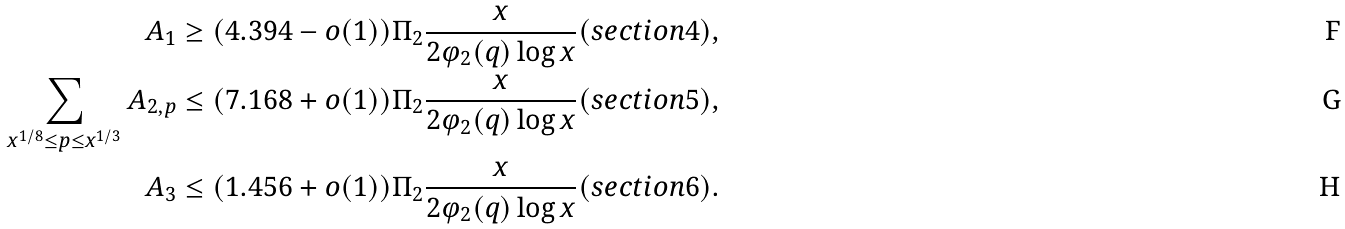Convert formula to latex. <formula><loc_0><loc_0><loc_500><loc_500>A _ { 1 } & \geq ( 4 . 3 9 4 - o ( 1 ) ) \Pi _ { 2 } \frac { x } { 2 \varphi _ { 2 } ( q ) \log x } ( s e c t i o n 4 ) , \\ \sum _ { x ^ { 1 / 8 } \leq p \leq x ^ { 1 / 3 } } A _ { 2 , p } & \leq ( 7 . 1 6 8 + o ( 1 ) ) \Pi _ { 2 } \frac { x } { 2 \varphi _ { 2 } ( q ) \log x } ( s e c t i o n 5 ) , \\ A _ { 3 } & \leq ( 1 . 4 5 6 + o ( 1 ) ) \Pi _ { 2 } \frac { x } { 2 \varphi _ { 2 } ( q ) \log x } ( s e c t i o n 6 ) .</formula> 